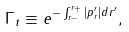Convert formula to latex. <formula><loc_0><loc_0><loc_500><loc_500>\Gamma _ { t } \equiv e ^ { - \int _ { r _ { - } } ^ { r _ { + } } | p _ { r } ^ { \prime } | d r ^ { \prime } } ,</formula> 